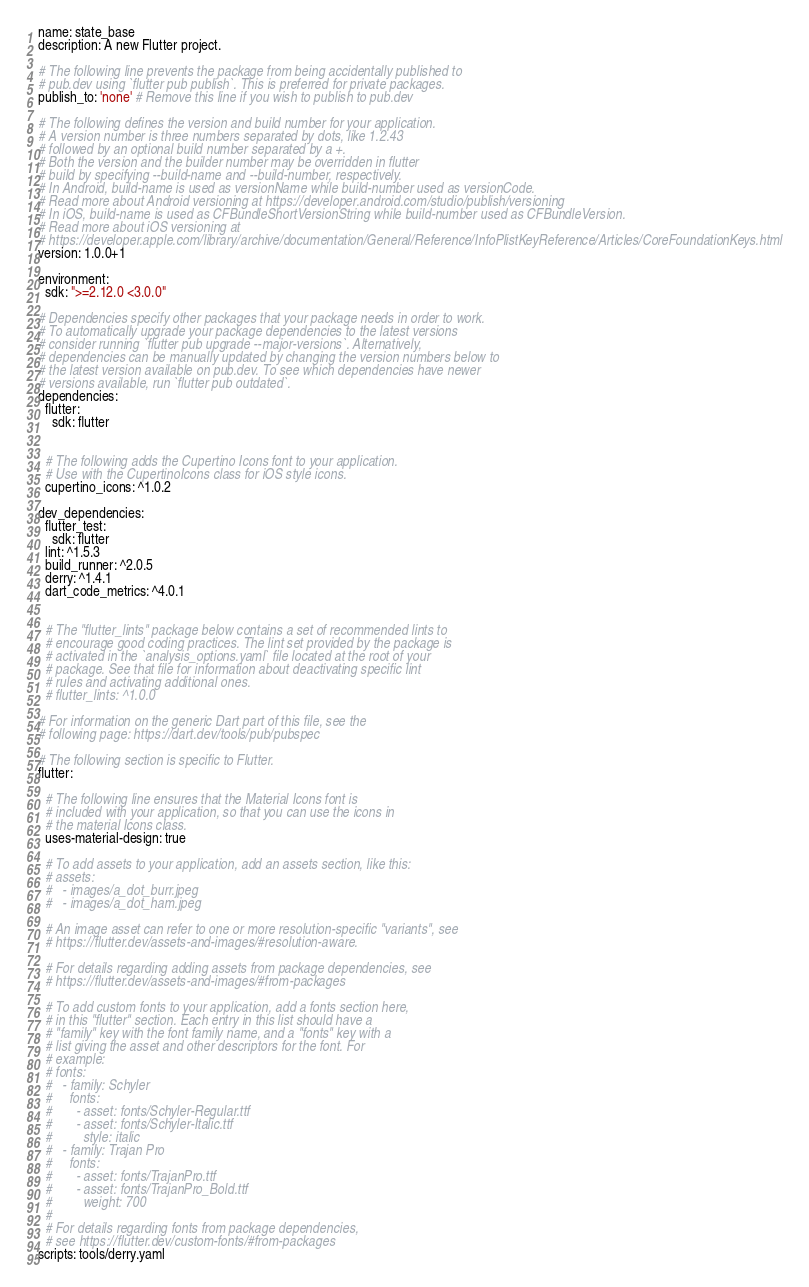<code> <loc_0><loc_0><loc_500><loc_500><_YAML_>name: state_base
description: A new Flutter project.

# The following line prevents the package from being accidentally published to
# pub.dev using `flutter pub publish`. This is preferred for private packages.
publish_to: 'none' # Remove this line if you wish to publish to pub.dev

# The following defines the version and build number for your application.
# A version number is three numbers separated by dots, like 1.2.43
# followed by an optional build number separated by a +.
# Both the version and the builder number may be overridden in flutter
# build by specifying --build-name and --build-number, respectively.
# In Android, build-name is used as versionName while build-number used as versionCode.
# Read more about Android versioning at https://developer.android.com/studio/publish/versioning
# In iOS, build-name is used as CFBundleShortVersionString while build-number used as CFBundleVersion.
# Read more about iOS versioning at
# https://developer.apple.com/library/archive/documentation/General/Reference/InfoPlistKeyReference/Articles/CoreFoundationKeys.html
version: 1.0.0+1

environment:
  sdk: ">=2.12.0 <3.0.0"

# Dependencies specify other packages that your package needs in order to work.
# To automatically upgrade your package dependencies to the latest versions
# consider running `flutter pub upgrade --major-versions`. Alternatively,
# dependencies can be manually updated by changing the version numbers below to
# the latest version available on pub.dev. To see which dependencies have newer
# versions available, run `flutter pub outdated`.
dependencies:
  flutter:
    sdk: flutter


  # The following adds the Cupertino Icons font to your application.
  # Use with the CupertinoIcons class for iOS style icons.
  cupertino_icons: ^1.0.2

dev_dependencies:
  flutter_test:
    sdk: flutter
  lint: ^1.5.3
  build_runner: ^2.0.5
  derry: ^1.4.1
  dart_code_metrics: ^4.0.1


  # The "flutter_lints" package below contains a set of recommended lints to
  # encourage good coding practices. The lint set provided by the package is
  # activated in the `analysis_options.yaml` file located at the root of your
  # package. See that file for information about deactivating specific lint
  # rules and activating additional ones.
  # flutter_lints: ^1.0.0

# For information on the generic Dart part of this file, see the
# following page: https://dart.dev/tools/pub/pubspec

# The following section is specific to Flutter.
flutter:

  # The following line ensures that the Material Icons font is
  # included with your application, so that you can use the icons in
  # the material Icons class.
  uses-material-design: true

  # To add assets to your application, add an assets section, like this:
  # assets:
  #   - images/a_dot_burr.jpeg
  #   - images/a_dot_ham.jpeg

  # An image asset can refer to one or more resolution-specific "variants", see
  # https://flutter.dev/assets-and-images/#resolution-aware.

  # For details regarding adding assets from package dependencies, see
  # https://flutter.dev/assets-and-images/#from-packages

  # To add custom fonts to your application, add a fonts section here,
  # in this "flutter" section. Each entry in this list should have a
  # "family" key with the font family name, and a "fonts" key with a
  # list giving the asset and other descriptors for the font. For
  # example:
  # fonts:
  #   - family: Schyler
  #     fonts:
  #       - asset: fonts/Schyler-Regular.ttf
  #       - asset: fonts/Schyler-Italic.ttf
  #         style: italic
  #   - family: Trajan Pro
  #     fonts:
  #       - asset: fonts/TrajanPro.ttf
  #       - asset: fonts/TrajanPro_Bold.ttf
  #         weight: 700
  #
  # For details regarding fonts from package dependencies,
  # see https://flutter.dev/custom-fonts/#from-packages
scripts: tools/derry.yaml</code> 